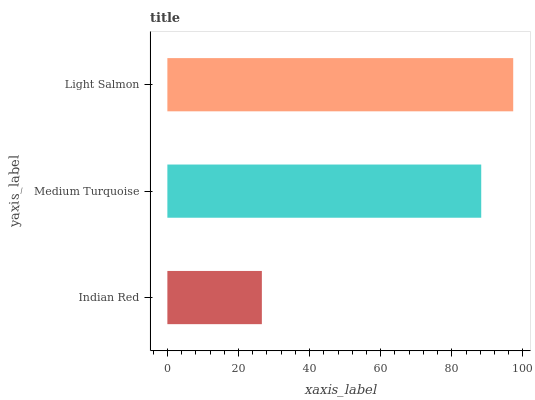Is Indian Red the minimum?
Answer yes or no. Yes. Is Light Salmon the maximum?
Answer yes or no. Yes. Is Medium Turquoise the minimum?
Answer yes or no. No. Is Medium Turquoise the maximum?
Answer yes or no. No. Is Medium Turquoise greater than Indian Red?
Answer yes or no. Yes. Is Indian Red less than Medium Turquoise?
Answer yes or no. Yes. Is Indian Red greater than Medium Turquoise?
Answer yes or no. No. Is Medium Turquoise less than Indian Red?
Answer yes or no. No. Is Medium Turquoise the high median?
Answer yes or no. Yes. Is Medium Turquoise the low median?
Answer yes or no. Yes. Is Light Salmon the high median?
Answer yes or no. No. Is Indian Red the low median?
Answer yes or no. No. 